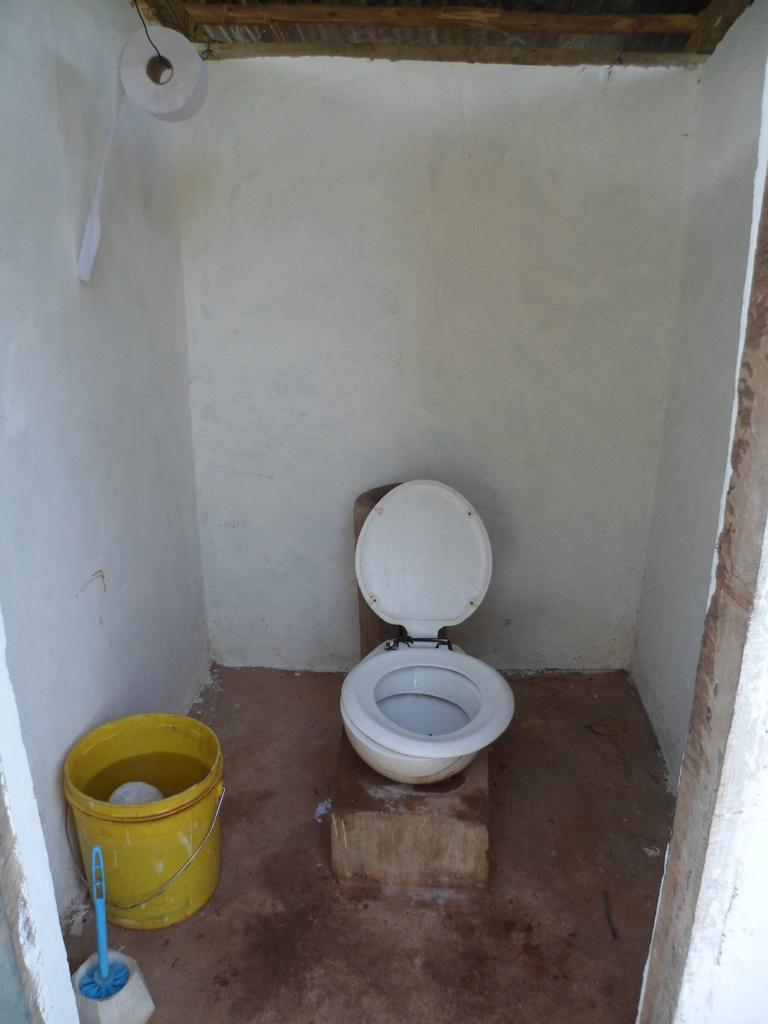What type of furniture is in the image? There is a commode in the image. What other object can be seen in the image? There is a bucket in the image. What is the liquid visible in the image? There is water visible in the image. What item is present for wiping or cleaning? There is a tissue roll in the image. What is visible in the background of the image? There is a wall in the background of the image. What type of rake is being used to make a statement in the image? There is no rake present in the image, and no one is making a statement. 